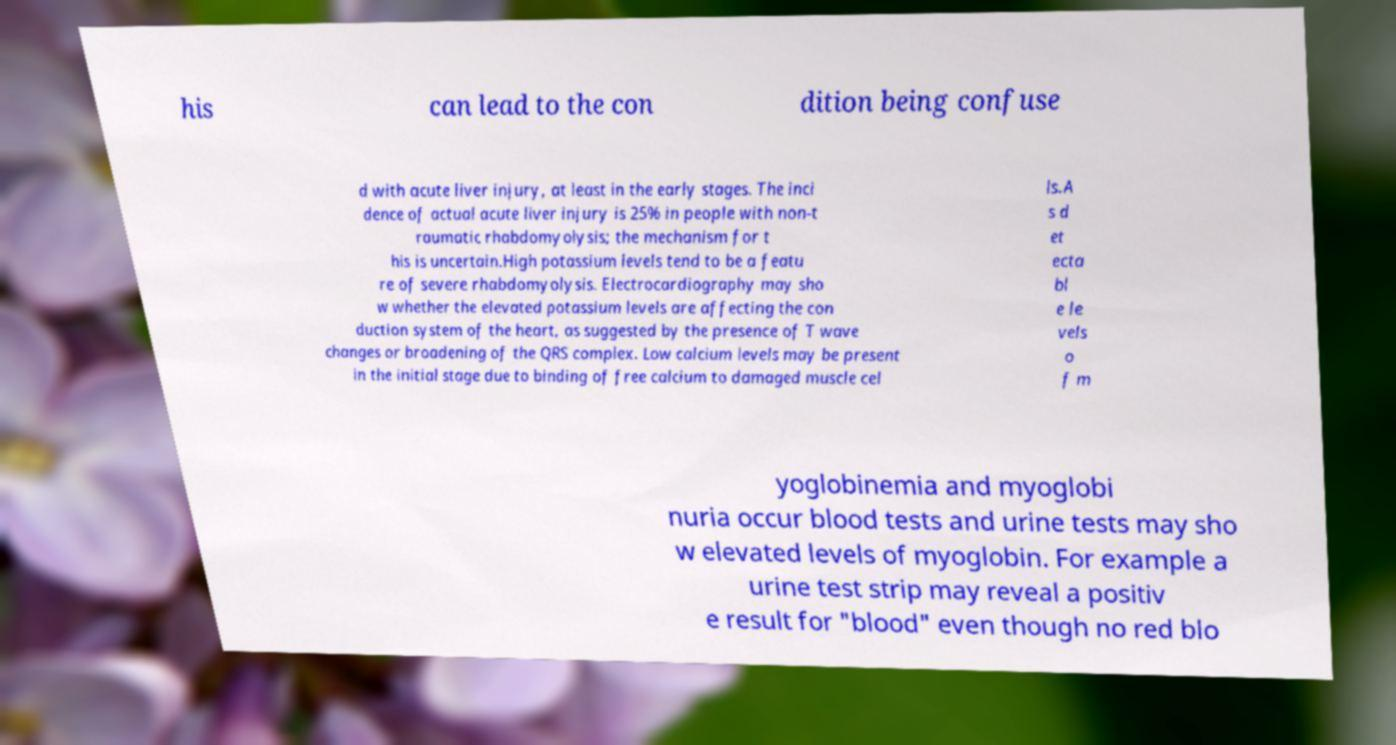Can you accurately transcribe the text from the provided image for me? his can lead to the con dition being confuse d with acute liver injury, at least in the early stages. The inci dence of actual acute liver injury is 25% in people with non-t raumatic rhabdomyolysis; the mechanism for t his is uncertain.High potassium levels tend to be a featu re of severe rhabdomyolysis. Electrocardiography may sho w whether the elevated potassium levels are affecting the con duction system of the heart, as suggested by the presence of T wave changes or broadening of the QRS complex. Low calcium levels may be present in the initial stage due to binding of free calcium to damaged muscle cel ls.A s d et ecta bl e le vels o f m yoglobinemia and myoglobi nuria occur blood tests and urine tests may sho w elevated levels of myoglobin. For example a urine test strip may reveal a positiv e result for "blood" even though no red blo 